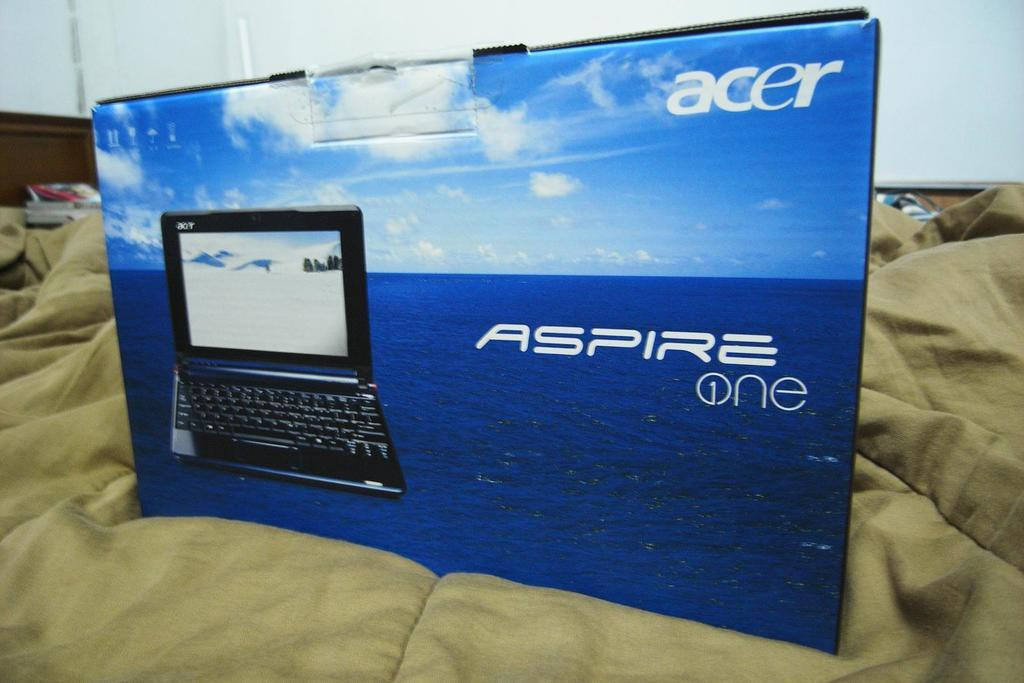<image>
Summarize the visual content of the image. A box that contains an Acer laptop sits on a bed. 